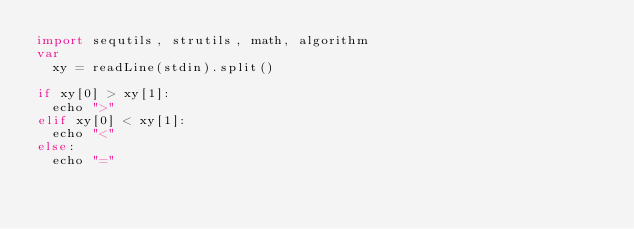Convert code to text. <code><loc_0><loc_0><loc_500><loc_500><_Nim_>import sequtils, strutils, math, algorithm
var
  xy = readLine(stdin).split()

if xy[0] > xy[1]:
  echo ">"
elif xy[0] < xy[1]:
  echo "<"
else:
  echo "="</code> 